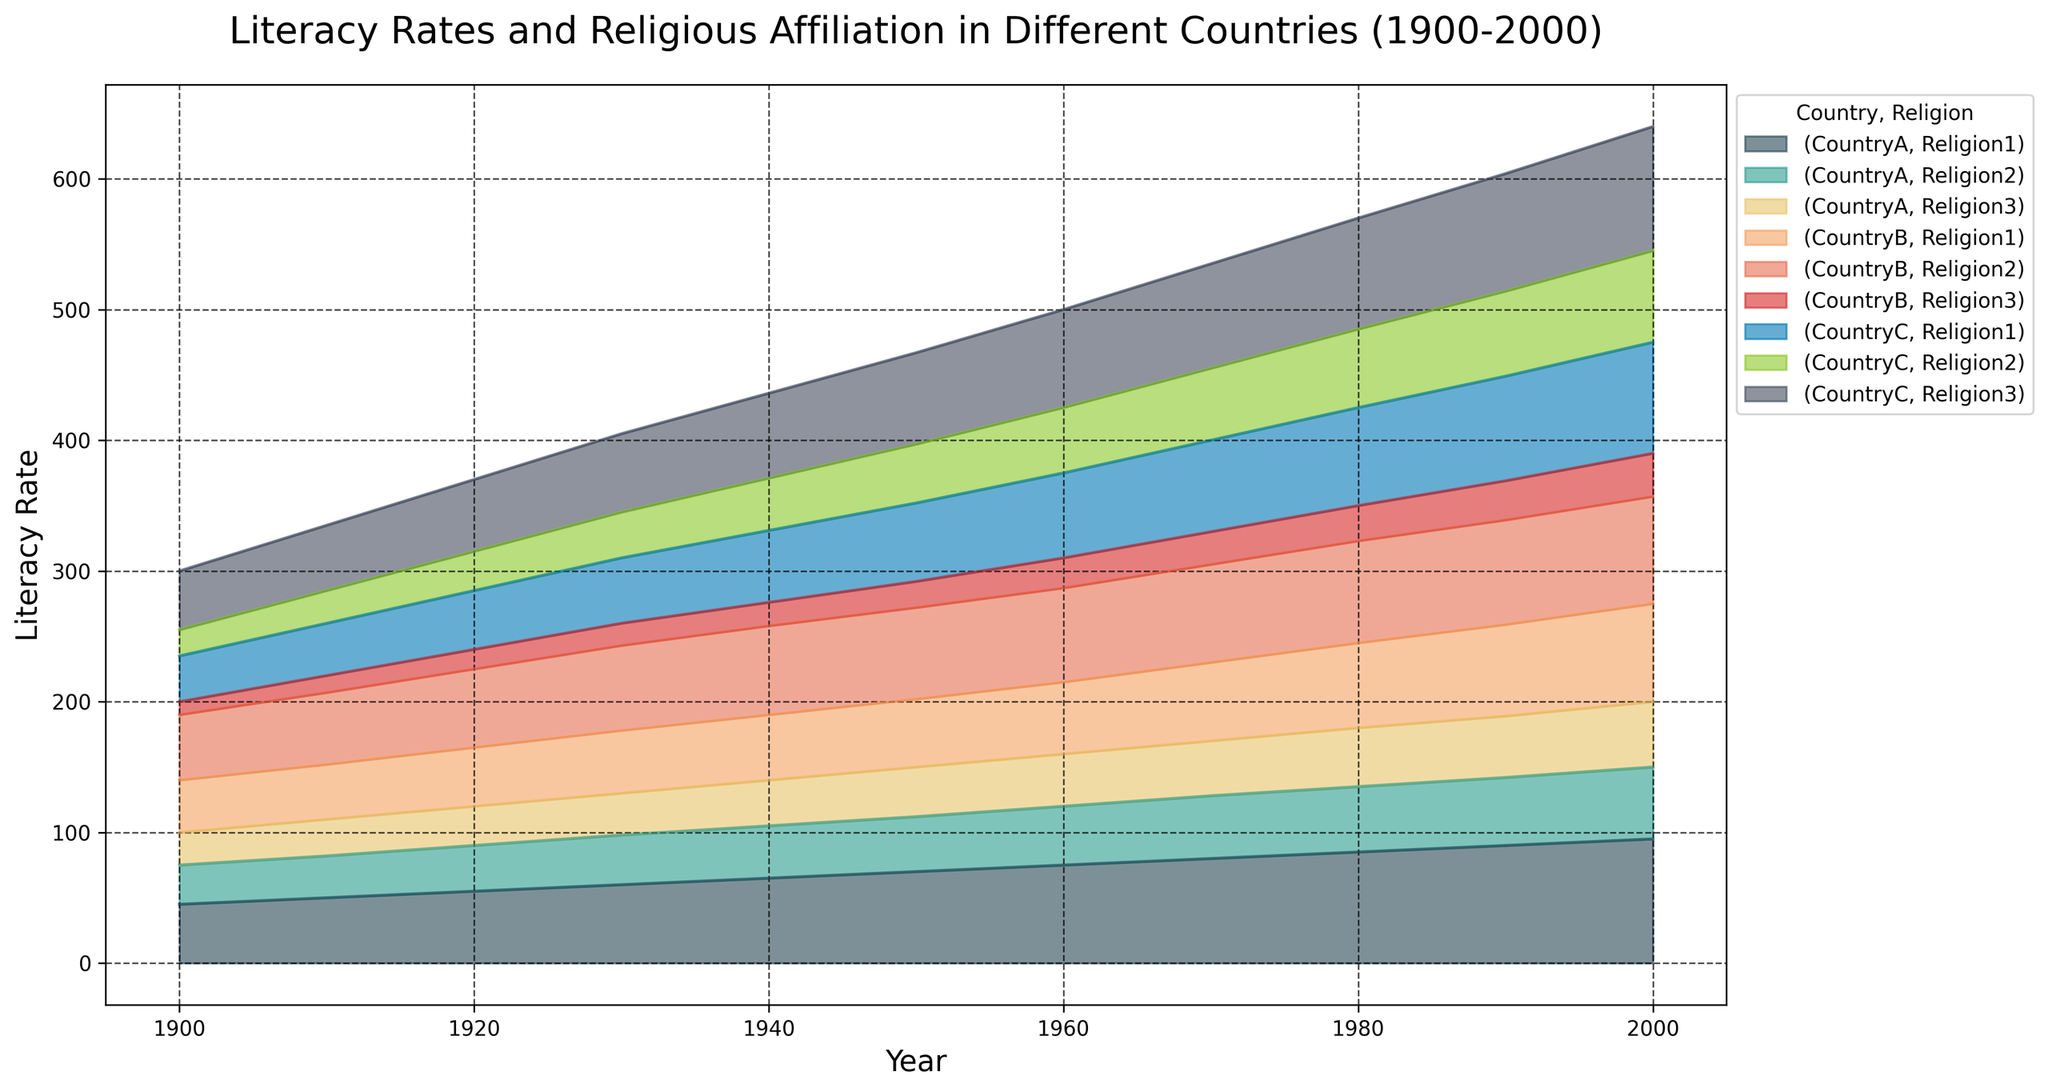How did the literacy rates for Religion1 in CountryA change from 1900 to 2000? To answer, look at the area representing Religion1 in CountryA. In 1900, the literacy rate was 45, and it progressively increased, reaching 95 in 2000.
Answer: It increased from 45 to 95 Which country had the highest literacy rate for Religion2 in 2000? In 2000, compare the heights of the areas representing Religion2 for each country. CountryB has the highest area for Religion2 in this year.
Answer: CountryB What was the difference in literacy rate for Religion3 between CountryB and CountryC in 1930? For 1930, locate Religion3 for both countries and subtract the two values. The literacy rates were 17 for CountryB and 60 for CountryC. The difference is 60 - 17 = 43.
Answer: 43 Which religion in CountryA showed the most significant growth in literacy rate from 1900 to 2000? Compare the growth of all three religions in CountryA by analyzing the area sizes. Religion1 increased from 45 to 95, Religion2 from 30 to 55, and Religion3 from 25 to 50. Religion1 has the most significant growth of 50.
Answer: Religion1 What is the average literacy rate for Religion3 across all countries in the year 1960? Sum the literacy rates for Religion3 in 1960 across all countries (40 + 23 + 75) and divide by the number of countries (3). The sum is 138, so the average is 138 / 3 = 46.
Answer: 46 In which year did CountryC attain a literacy rate of at least 50% for all religions? Analyze the areas for CountryC to find the year when the literacy rates for all three religions exceed 50%. This first occurs in 1970, where all rates (70, 55, 80) are over 50.
Answer: 1970 Which religion in CountryB experienced the least change in literacy rate between 1900 and 2000? Compare the change in literacy rates for all three religions in CountryB from 1900 to 2000. Religion1 changed from 40 to 75 (35), Religion2 from 50 to 82 (32), and Religion3 from 10 to 33 (23). Religion3 experienced the least change of 23.
Answer: Religion3 What is the sum of literacy rates for all religions in CountryA in 1950? Add the literacy rates for all three religions in CountryA in 1950. Sum: 70 (Religion1) + 42 (Religion2) + 38 (Religion3) = 150.
Answer: 150 Did the literacy rate for Religion1 in CountryB ever decline? Examine the trend for Religion1 in CountryB by following the corresponding area over the years. It continuously increases from 1900 (40) to 2000 (75).
Answer: No Which religion had the highest average literacy rate in CountryC over the entire century? Calculate and compare the average literacy rates for each religion in CountryC over all the years from 1900 to 2000. Religion1 averages: (35+40+45+50+55+60+65+70+75+80+85)/11, Religion2: (20+25+30+35+40+45+50+55+60+65+70)/11, and Religion3: (45+50+55+60+65+70+75+80+85+90+95)/11. Religion3 has the highest average.
Answer: Religion3 